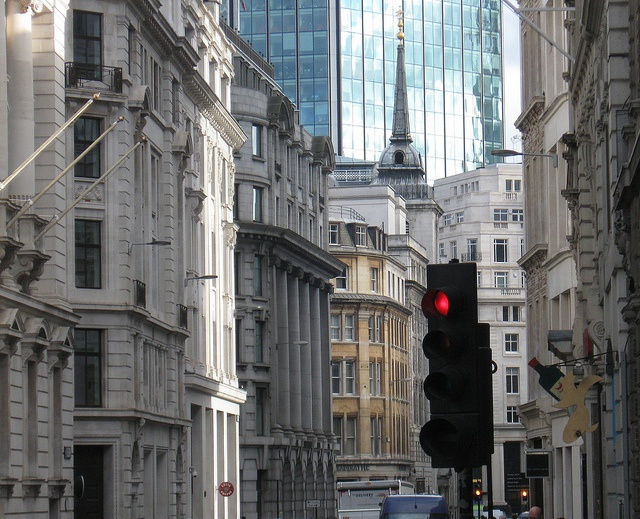Describe the objects in this image and their specific colors. I can see traffic light in darkgray, black, gray, and brown tones, truck in darkgray, gray, and black tones, car in darkgray, gray, black, darkblue, and navy tones, bottle in darkgray, black, gray, darkgreen, and maroon tones, and people in darkgray, black, gray, and maroon tones in this image. 